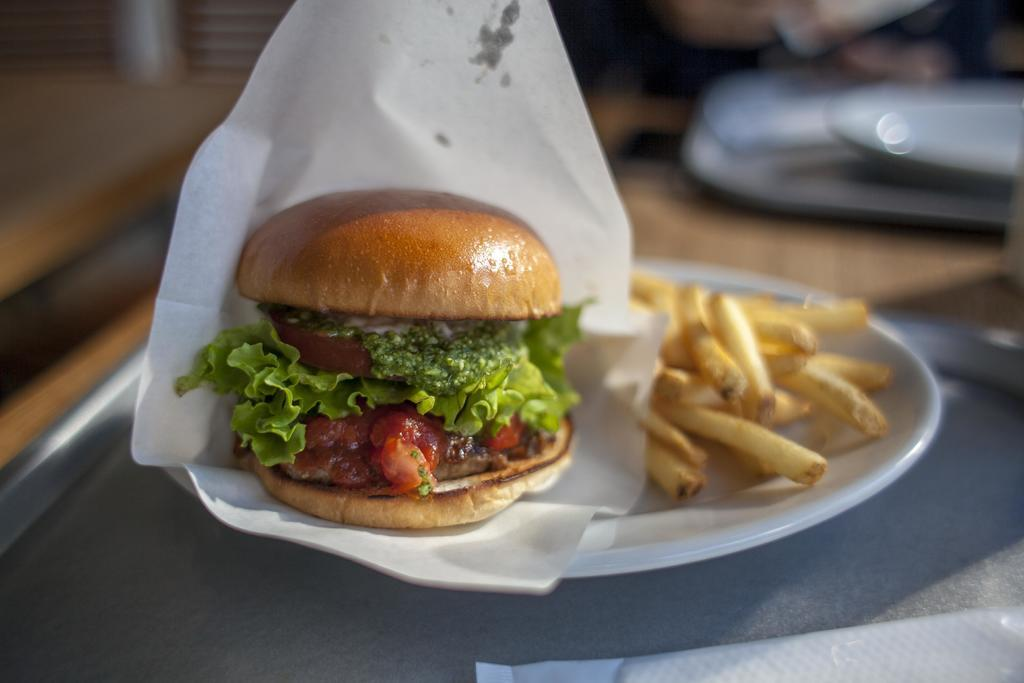What type of food is visible in the image? There is a burger and french fries in the image. What is the color of the plate on which the food is placed? The burger and french fries are on a white color plate. What is located at the bottom of the image? A tray and tissue are present at the bottom of the image. What type of watch is visible on the burger in the image? There is no watch present on the burger in the image. What amusement park can be seen in the background of the image? There is no amusement park visible in the image; it only features a burger, french fries, a white plate, a tray, and tissue. 